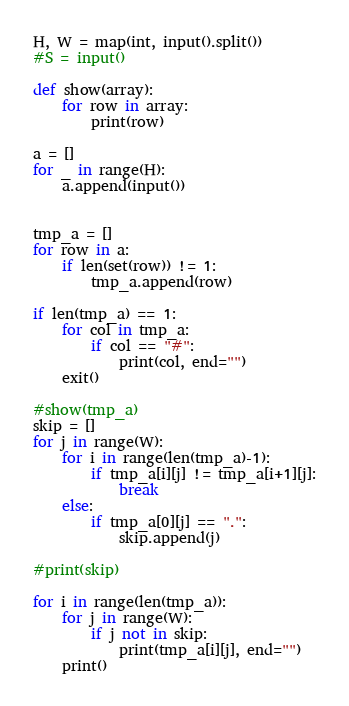Convert code to text. <code><loc_0><loc_0><loc_500><loc_500><_Python_>H, W = map(int, input().split())
#S = input()

def show(array):
    for row in array:
        print(row)

a = []
for _ in range(H):
    a.append(input())


tmp_a = []
for row in a:
    if len(set(row)) != 1:
        tmp_a.append(row)

if len(tmp_a) == 1:
    for col in tmp_a:
        if col == "#":
            print(col, end="")
    exit()

#show(tmp_a)
skip = []
for j in range(W):
    for i in range(len(tmp_a)-1):
        if tmp_a[i][j] != tmp_a[i+1][j]:
            break
    else:
        if tmp_a[0][j] == ".":
            skip.append(j)

#print(skip)

for i in range(len(tmp_a)):
    for j in range(W):
        if j not in skip:
            print(tmp_a[i][j], end="")
    print()</code> 